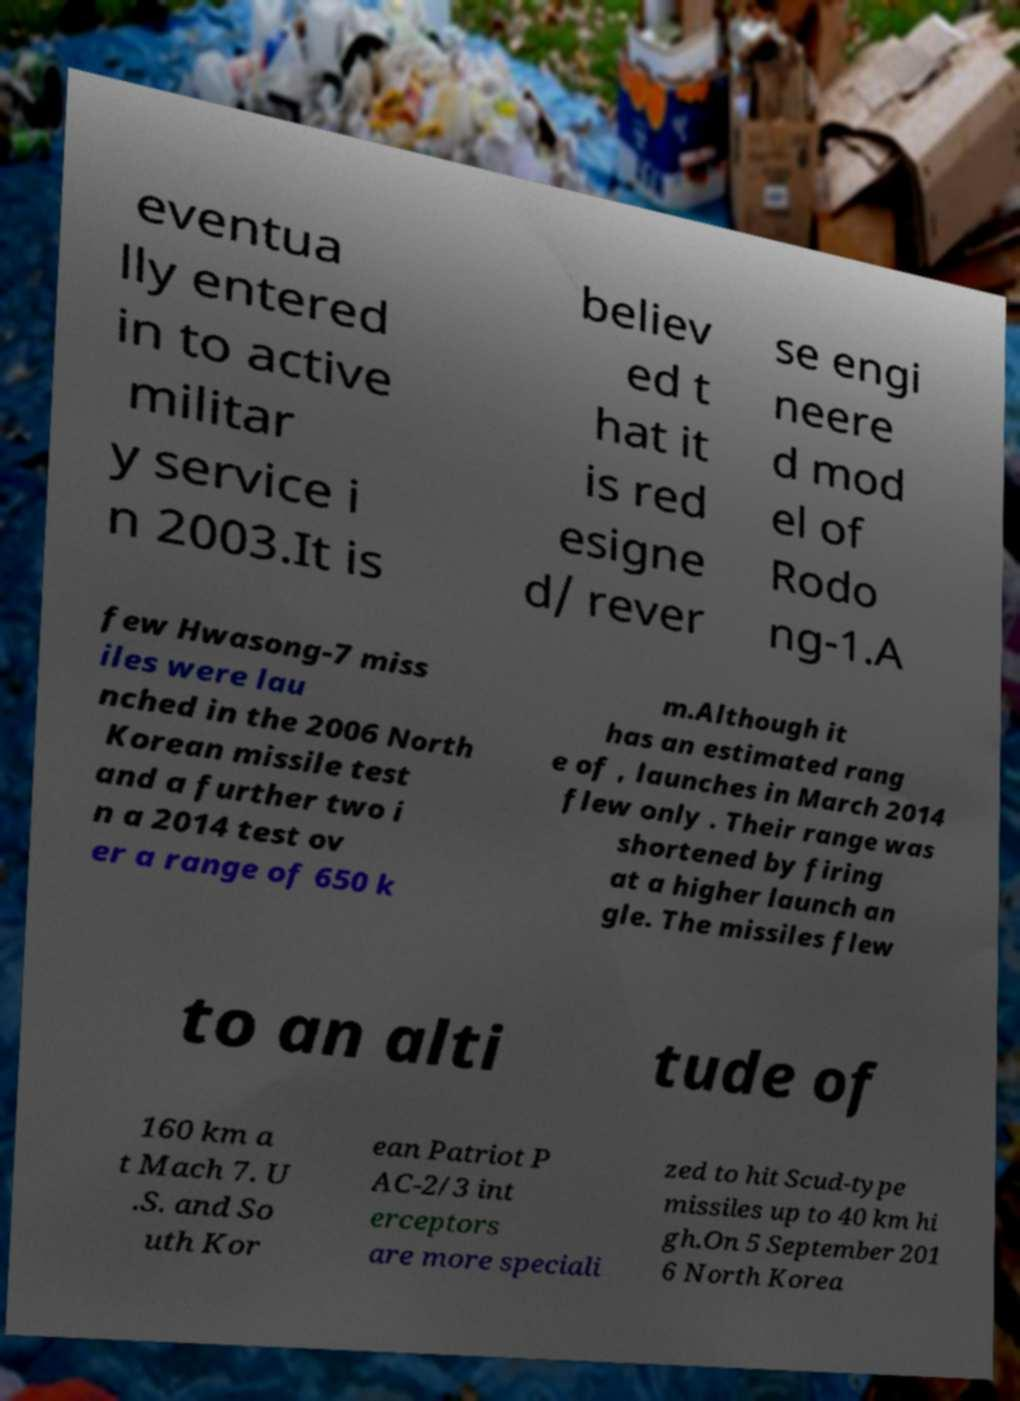I need the written content from this picture converted into text. Can you do that? eventua lly entered in to active militar y service i n 2003.It is believ ed t hat it is red esigne d/ rever se engi neere d mod el of Rodo ng-1.A few Hwasong-7 miss iles were lau nched in the 2006 North Korean missile test and a further two i n a 2014 test ov er a range of 650 k m.Although it has an estimated rang e of , launches in March 2014 flew only . Their range was shortened by firing at a higher launch an gle. The missiles flew to an alti tude of 160 km a t Mach 7. U .S. and So uth Kor ean Patriot P AC-2/3 int erceptors are more speciali zed to hit Scud-type missiles up to 40 km hi gh.On 5 September 201 6 North Korea 